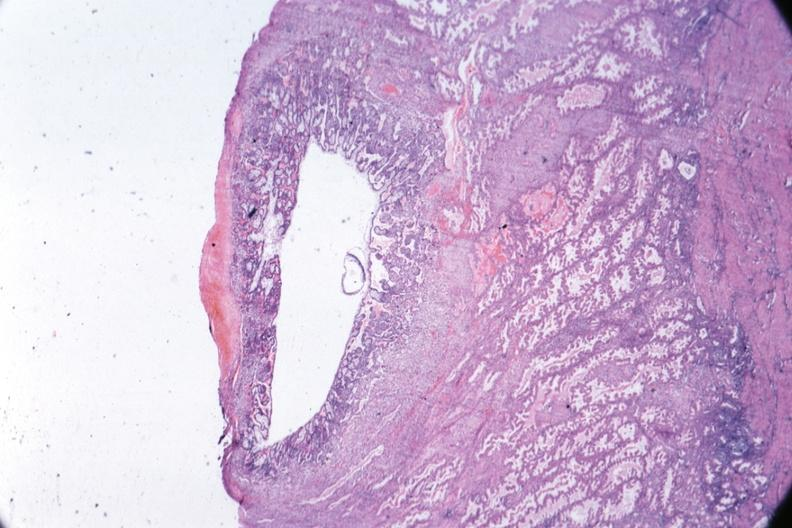where is this from?
Answer the question using a single word or phrase. Female reproductive system 